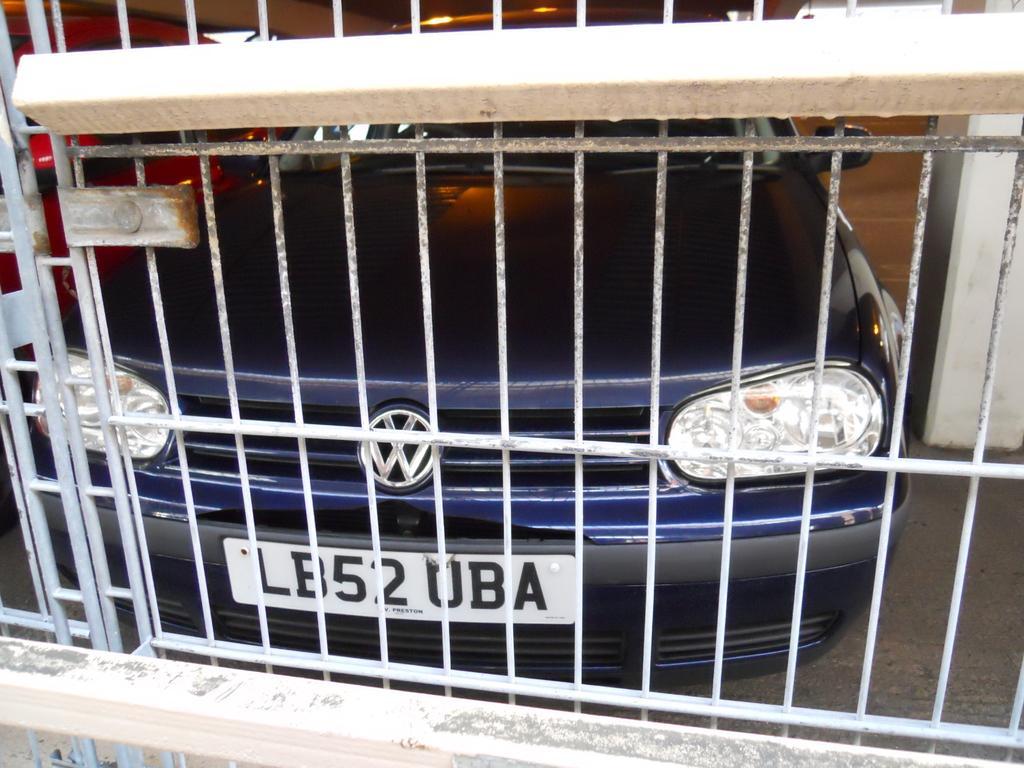How would you summarize this image in a sentence or two? In the image it looks like there is a gate and behind the gate there are two cars visible in the image. 